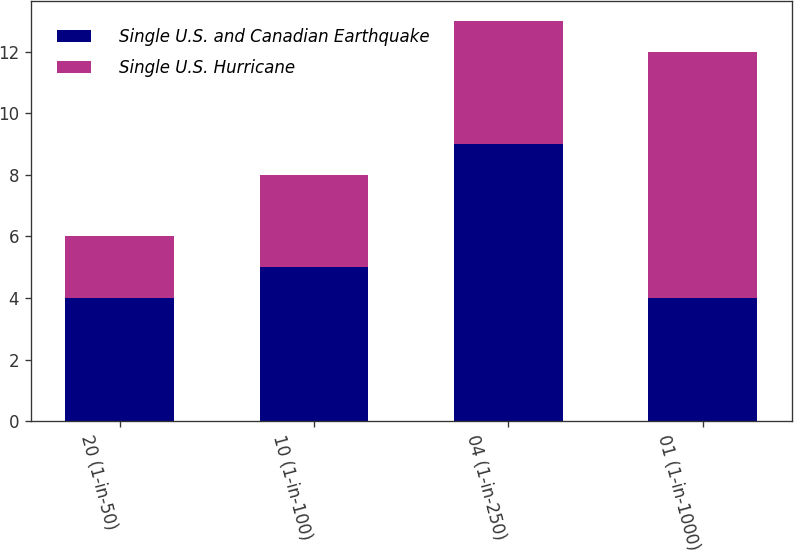<chart> <loc_0><loc_0><loc_500><loc_500><stacked_bar_chart><ecel><fcel>20 (1-in-50)<fcel>10 (1-in-100)<fcel>04 (1-in-250)<fcel>01 (1-in-1000)<nl><fcel>Single U.S. and Canadian Earthquake<fcel>4<fcel>5<fcel>9<fcel>4<nl><fcel>Single U.S. Hurricane<fcel>2<fcel>3<fcel>4<fcel>8<nl></chart> 